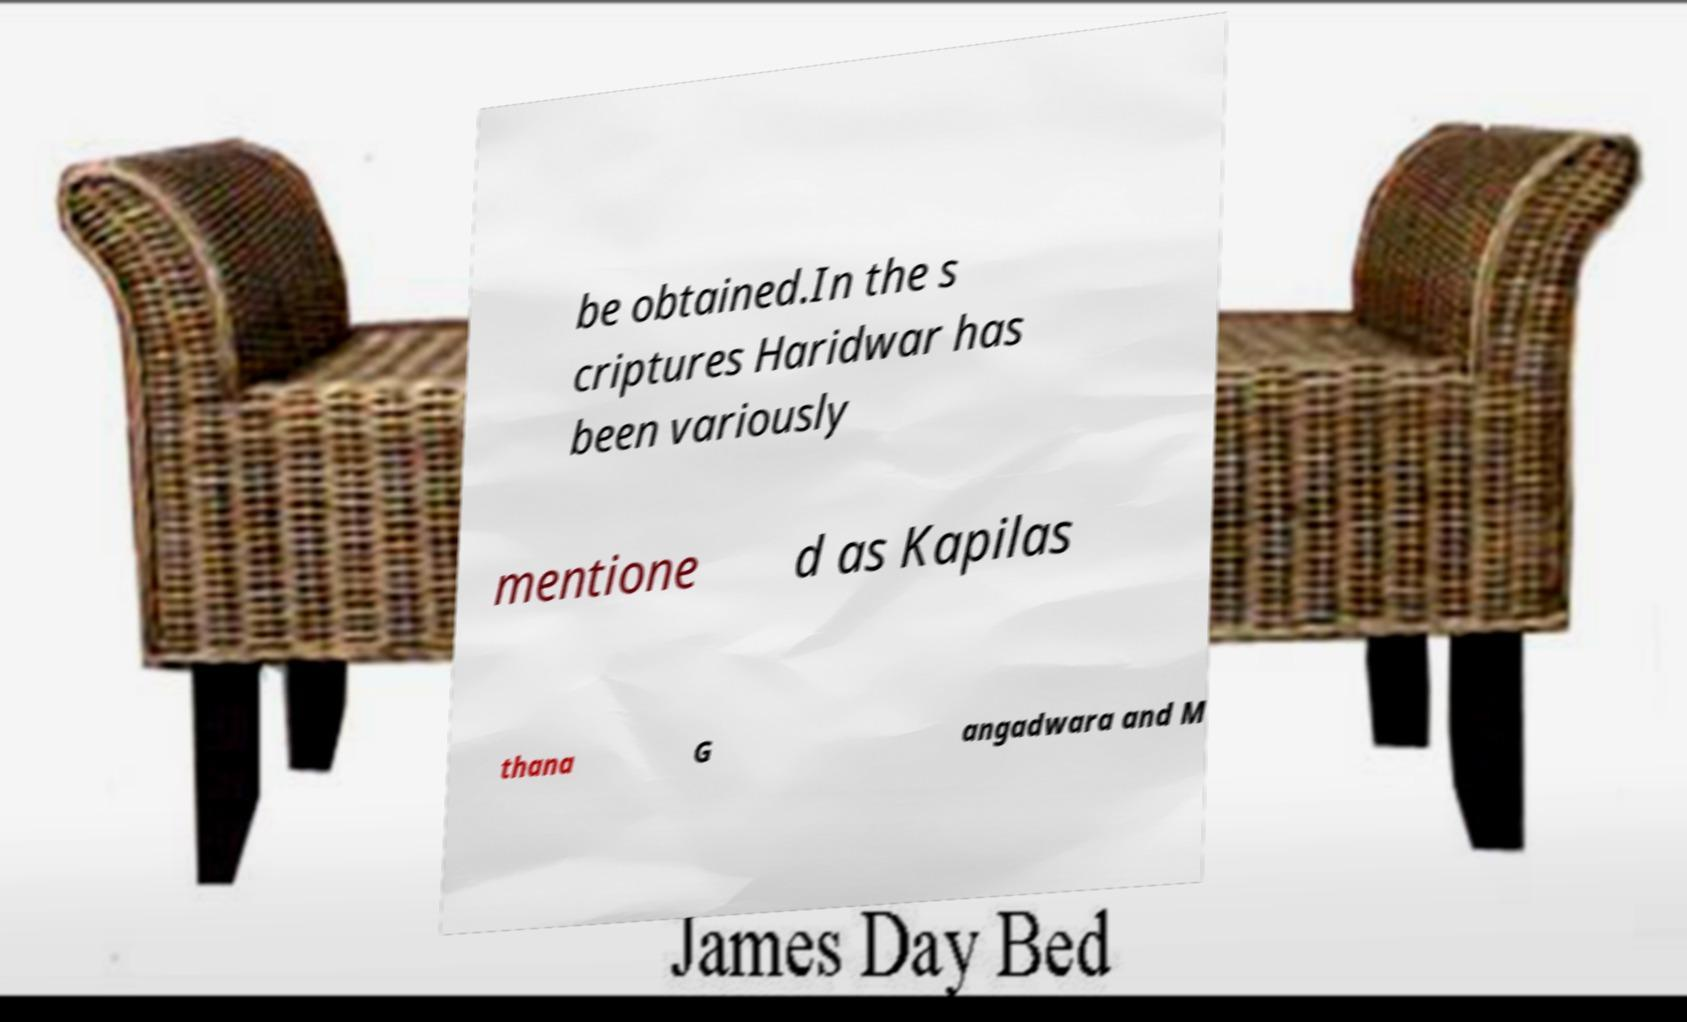Please read and relay the text visible in this image. What does it say? be obtained.In the s criptures Haridwar has been variously mentione d as Kapilas thana G angadwara and M 